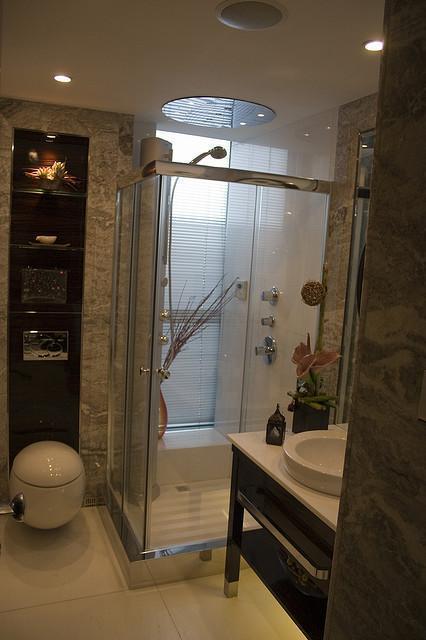How many white stuffed bears are there?
Give a very brief answer. 0. 